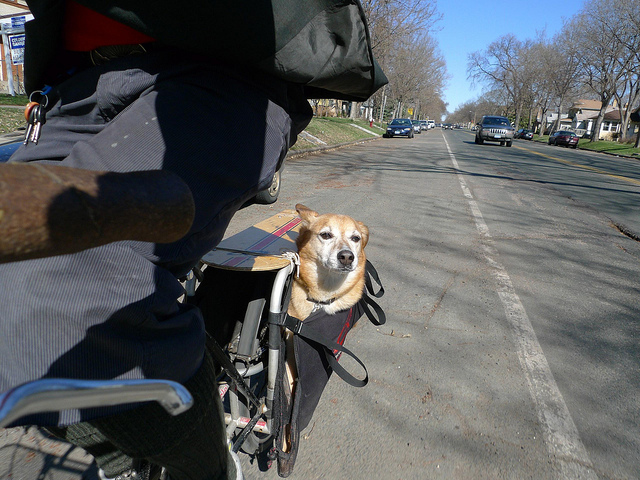What breed might this dog be? Based on its physical characteristics, the dog could be a Corgi or a mixed breed with predominant Corgi features. It has a short stature, erect ears, and a fox-like face, which are typical of Corgis. 